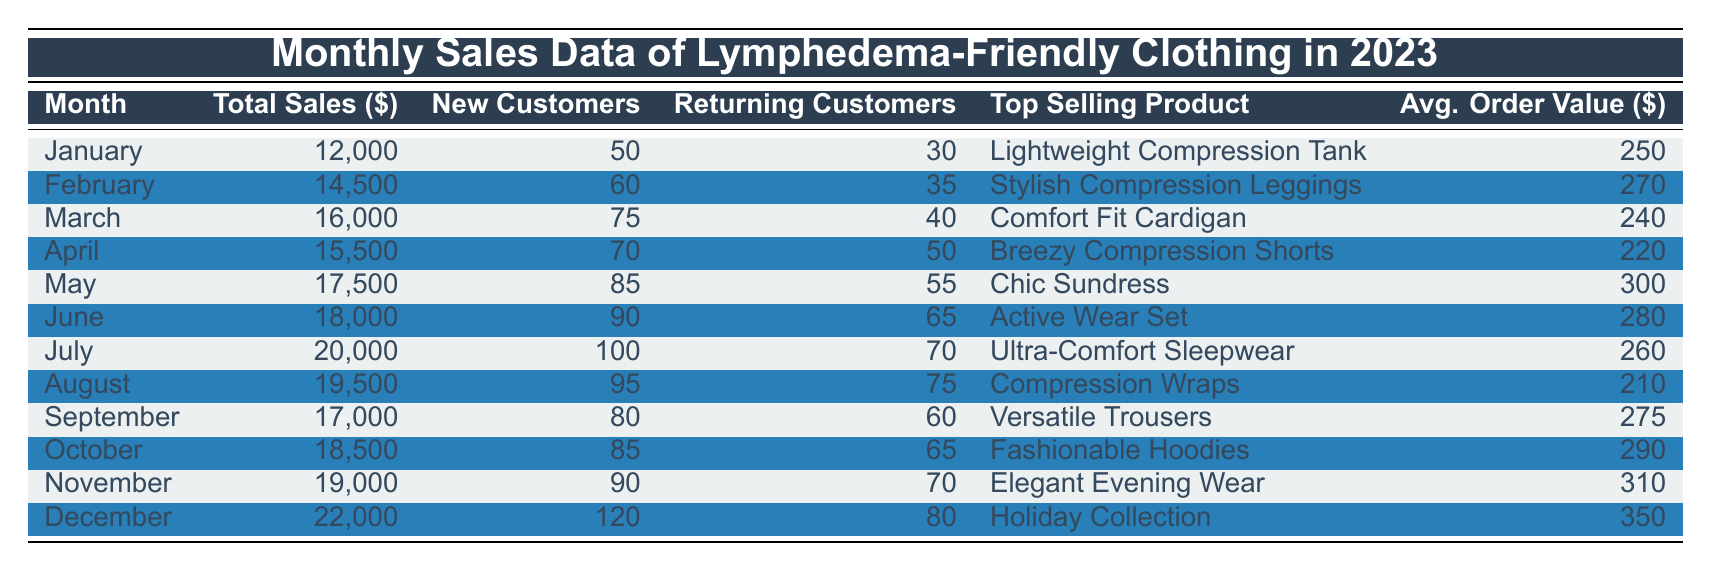What was the total sales in December? December's total sales are listed in the table as 22,000.
Answer: 22,000 Which month had the highest number of new customers? The table shows the number of new customers for each month. July has the highest number with 100 new customers.
Answer: July What is the average order value in October? The average order value in October is directly listed in the table as 290.
Answer: 290 How many new customers did we have from January to March combined? Adding the new customers from January (50), February (60), and March (75) gives a total of 50 + 60 + 75 = 185 new customers.
Answer: 185 Is the top-selling product in November more expensive than in May? In November, the top-selling product's average order value is 310, while in May it is 300. Since 310 is greater than 300, the answer is yes.
Answer: Yes What was the increase in total sales from January to December? The total sales for January and December are 12,000 and 22,000 respectively. The increase is calculated as 22,000 - 12,000 = 10,000.
Answer: 10,000 Which month had the lowest average order value, and what was it? The average order values are compared across all months, and April has the lowest average order value at 220.
Answer: April, 220 How many returning customers were there in total from April to June? The returning customers in April (50), May (55), and June (65) can be summed to find the total: 50 + 55 + 65 = 170 returning customers.
Answer: 170 Did more customers return in July than in September? July had 70 returning customers while September had 60. Since 70 is greater than 60, the answer is yes.
Answer: Yes 